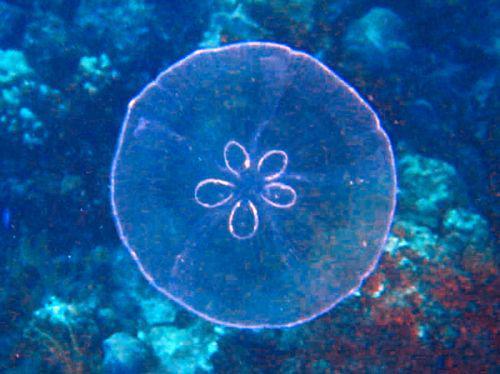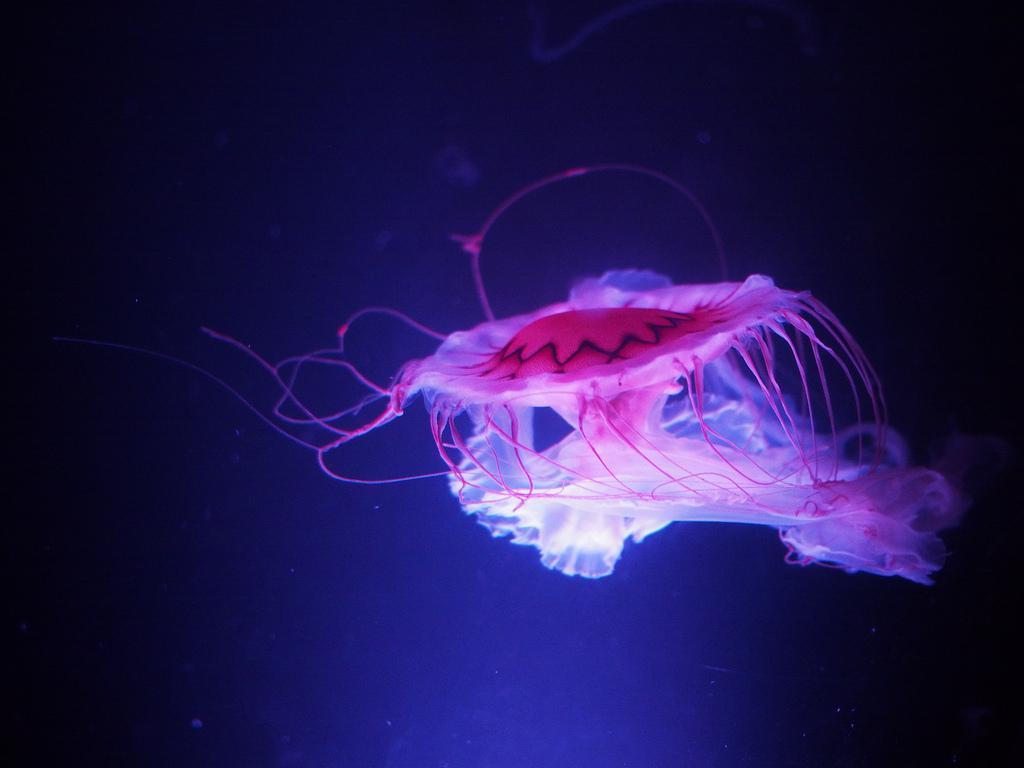The first image is the image on the left, the second image is the image on the right. For the images displayed, is the sentence "there are two jellyfish in the image pair" factually correct? Answer yes or no. Yes. The first image is the image on the left, the second image is the image on the right. Evaluate the accuracy of this statement regarding the images: "One jellyfish has long tentacles.". Is it true? Answer yes or no. No. 